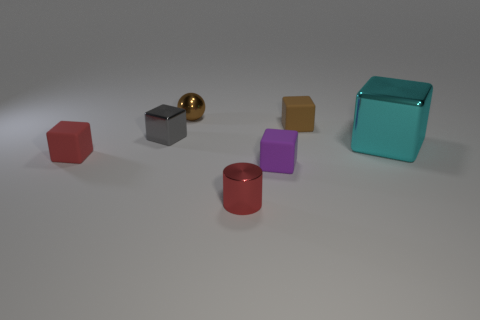Subtract all tiny brown blocks. How many blocks are left? 4 Subtract all red blocks. How many blocks are left? 4 Subtract all green blocks. Subtract all brown cylinders. How many blocks are left? 5 Add 2 brown matte objects. How many objects exist? 9 Subtract all cylinders. How many objects are left? 6 Subtract 1 red cylinders. How many objects are left? 6 Subtract all brown things. Subtract all matte cubes. How many objects are left? 2 Add 2 brown metal things. How many brown metal things are left? 3 Add 5 red shiny cylinders. How many red shiny cylinders exist? 6 